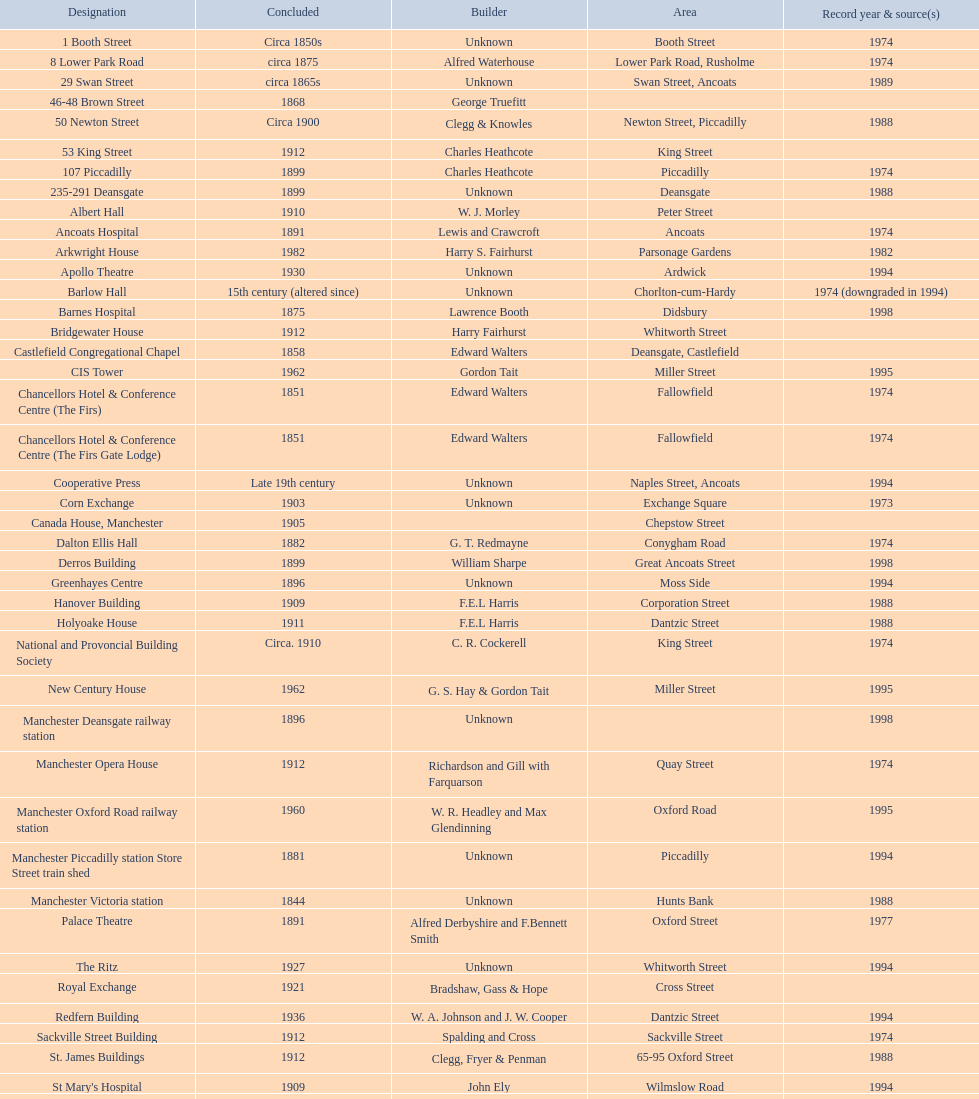How many buildings had alfred waterhouse as their architect? 3. 